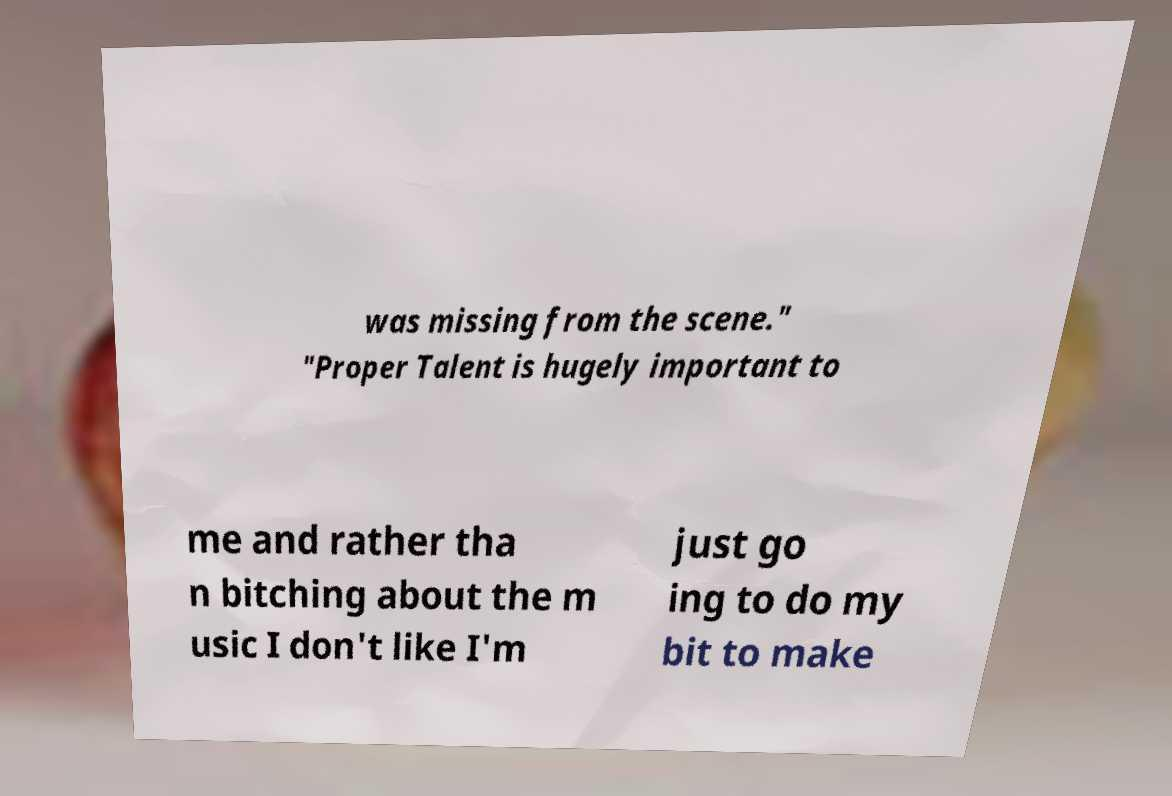I need the written content from this picture converted into text. Can you do that? was missing from the scene." "Proper Talent is hugely important to me and rather tha n bitching about the m usic I don't like I'm just go ing to do my bit to make 